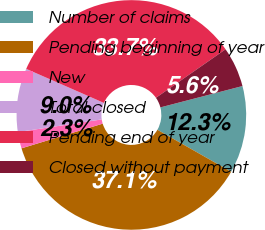Convert chart to OTSL. <chart><loc_0><loc_0><loc_500><loc_500><pie_chart><fcel>Number of claims<fcel>Pending beginning of year<fcel>New<fcel>Total closed<fcel>Pending end of year<fcel>Closed without payment<nl><fcel>12.29%<fcel>37.07%<fcel>2.31%<fcel>8.96%<fcel>33.74%<fcel>5.64%<nl></chart> 